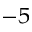<formula> <loc_0><loc_0><loc_500><loc_500>^ { - 5 }</formula> 